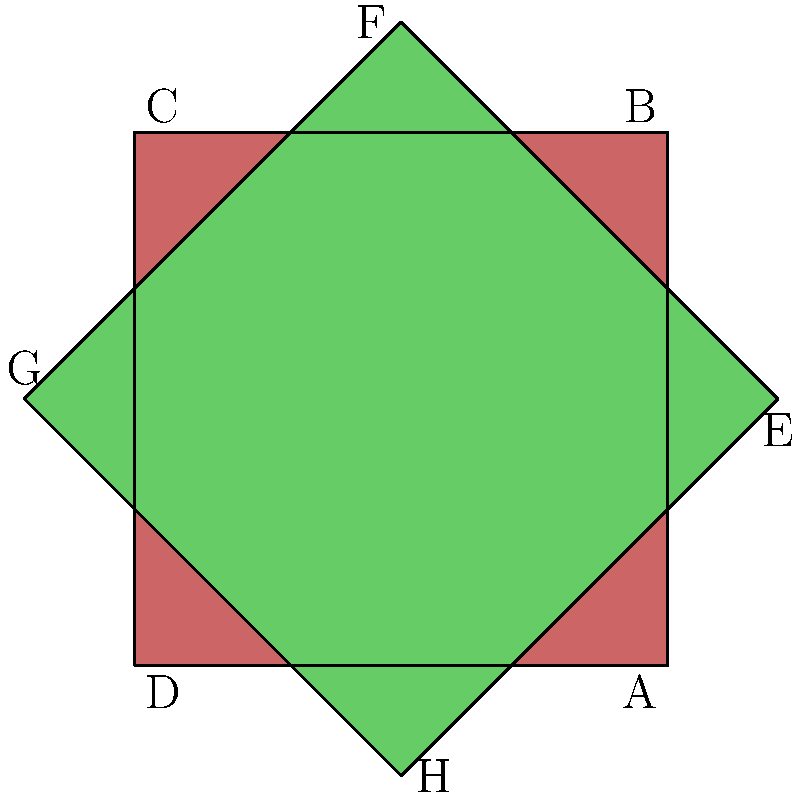In this traditional Puerto Rican tile design, which pairs of triangles are congruent? To identify congruent triangles in this design, we need to follow these steps:

1. Observe that the design consists of two overlapping squares, one red and one green.

2. The red square is divided into four congruent right triangles by its diagonals.

3. The green square is rotated 45 degrees and also divided into four congruent right triangles.

4. In the red square:
   - Triangle ABD is congruent to triangle BCD
   - Triangle ABC is congruent to triangle ACD

5. In the green square:
   - Triangle EFG is congruent to triangle FGH
   - Triangle EFH is congruent to triangle EGH

6. Additionally, all eight triangles (four red and four green) are congruent to each other because:
   - They are all right triangles
   - They all share the same hypotenuse length (side of the square)
   - They all have 45-45-90 degree angles

Therefore, all possible pairs of triangles in this design are congruent.
Answer: All pairs 